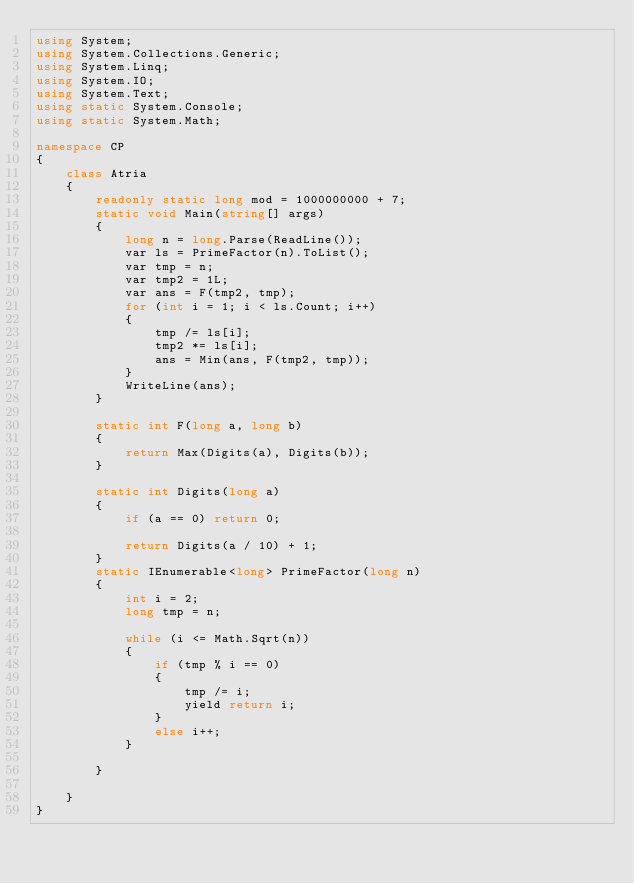<code> <loc_0><loc_0><loc_500><loc_500><_C#_>using System;
using System.Collections.Generic;
using System.Linq;
using System.IO;
using System.Text;
using static System.Console;
using static System.Math;

namespace CP
{
    class Atria
    {
        readonly static long mod = 1000000000 + 7;
        static void Main(string[] args)
        {
            long n = long.Parse(ReadLine());
            var ls = PrimeFactor(n).ToList();
            var tmp = n;
            var tmp2 = 1L;
            var ans = F(tmp2, tmp);
            for (int i = 1; i < ls.Count; i++)
            {
                tmp /= ls[i];
                tmp2 *= ls[i];
                ans = Min(ans, F(tmp2, tmp));
            }
            WriteLine(ans);
        }

        static int F(long a, long b)
        {
            return Max(Digits(a), Digits(b));
        }

        static int Digits(long a)
        {
            if (a == 0) return 0;

            return Digits(a / 10) + 1;
        }
        static IEnumerable<long> PrimeFactor(long n)
        {
            int i = 2;
            long tmp = n;

            while (i <= Math.Sqrt(n))
            {
                if (tmp % i == 0)
                {
                    tmp /= i;
                    yield return i;
                }
                else i++;
            }

        }

    }
}
</code> 